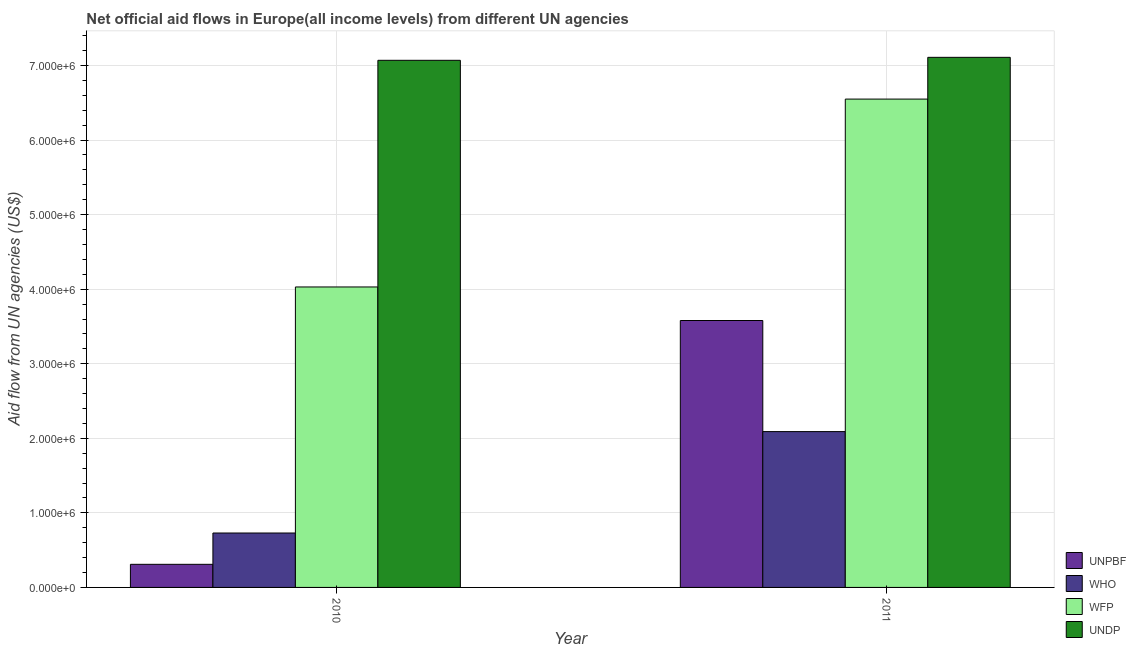How many different coloured bars are there?
Keep it short and to the point. 4. How many groups of bars are there?
Provide a short and direct response. 2. Are the number of bars on each tick of the X-axis equal?
Offer a very short reply. Yes. How many bars are there on the 2nd tick from the left?
Ensure brevity in your answer.  4. How many bars are there on the 1st tick from the right?
Make the answer very short. 4. What is the label of the 2nd group of bars from the left?
Your response must be concise. 2011. What is the amount of aid given by undp in 2010?
Your answer should be very brief. 7.07e+06. Across all years, what is the maximum amount of aid given by wfp?
Your answer should be compact. 6.55e+06. Across all years, what is the minimum amount of aid given by wfp?
Keep it short and to the point. 4.03e+06. In which year was the amount of aid given by unpbf maximum?
Keep it short and to the point. 2011. What is the total amount of aid given by unpbf in the graph?
Keep it short and to the point. 3.89e+06. What is the difference between the amount of aid given by undp in 2010 and that in 2011?
Provide a succinct answer. -4.00e+04. What is the difference between the amount of aid given by unpbf in 2010 and the amount of aid given by undp in 2011?
Provide a succinct answer. -3.27e+06. What is the average amount of aid given by who per year?
Offer a terse response. 1.41e+06. What is the ratio of the amount of aid given by undp in 2010 to that in 2011?
Offer a terse response. 0.99. Is the amount of aid given by who in 2010 less than that in 2011?
Offer a terse response. Yes. In how many years, is the amount of aid given by wfp greater than the average amount of aid given by wfp taken over all years?
Your response must be concise. 1. What does the 2nd bar from the left in 2011 represents?
Provide a short and direct response. WHO. What does the 1st bar from the right in 2010 represents?
Offer a very short reply. UNDP. Is it the case that in every year, the sum of the amount of aid given by unpbf and amount of aid given by who is greater than the amount of aid given by wfp?
Provide a short and direct response. No. Are all the bars in the graph horizontal?
Provide a short and direct response. No. How many years are there in the graph?
Provide a succinct answer. 2. What is the title of the graph?
Make the answer very short. Net official aid flows in Europe(all income levels) from different UN agencies. What is the label or title of the Y-axis?
Your answer should be very brief. Aid flow from UN agencies (US$). What is the Aid flow from UN agencies (US$) in WHO in 2010?
Provide a succinct answer. 7.30e+05. What is the Aid flow from UN agencies (US$) of WFP in 2010?
Your response must be concise. 4.03e+06. What is the Aid flow from UN agencies (US$) in UNDP in 2010?
Give a very brief answer. 7.07e+06. What is the Aid flow from UN agencies (US$) of UNPBF in 2011?
Keep it short and to the point. 3.58e+06. What is the Aid flow from UN agencies (US$) of WHO in 2011?
Your answer should be very brief. 2.09e+06. What is the Aid flow from UN agencies (US$) of WFP in 2011?
Make the answer very short. 6.55e+06. What is the Aid flow from UN agencies (US$) in UNDP in 2011?
Your answer should be compact. 7.11e+06. Across all years, what is the maximum Aid flow from UN agencies (US$) in UNPBF?
Offer a terse response. 3.58e+06. Across all years, what is the maximum Aid flow from UN agencies (US$) in WHO?
Your response must be concise. 2.09e+06. Across all years, what is the maximum Aid flow from UN agencies (US$) in WFP?
Make the answer very short. 6.55e+06. Across all years, what is the maximum Aid flow from UN agencies (US$) of UNDP?
Make the answer very short. 7.11e+06. Across all years, what is the minimum Aid flow from UN agencies (US$) in UNPBF?
Keep it short and to the point. 3.10e+05. Across all years, what is the minimum Aid flow from UN agencies (US$) of WHO?
Your answer should be very brief. 7.30e+05. Across all years, what is the minimum Aid flow from UN agencies (US$) of WFP?
Give a very brief answer. 4.03e+06. Across all years, what is the minimum Aid flow from UN agencies (US$) of UNDP?
Your response must be concise. 7.07e+06. What is the total Aid flow from UN agencies (US$) of UNPBF in the graph?
Provide a short and direct response. 3.89e+06. What is the total Aid flow from UN agencies (US$) of WHO in the graph?
Give a very brief answer. 2.82e+06. What is the total Aid flow from UN agencies (US$) in WFP in the graph?
Give a very brief answer. 1.06e+07. What is the total Aid flow from UN agencies (US$) of UNDP in the graph?
Your response must be concise. 1.42e+07. What is the difference between the Aid flow from UN agencies (US$) in UNPBF in 2010 and that in 2011?
Your answer should be compact. -3.27e+06. What is the difference between the Aid flow from UN agencies (US$) in WHO in 2010 and that in 2011?
Offer a very short reply. -1.36e+06. What is the difference between the Aid flow from UN agencies (US$) of WFP in 2010 and that in 2011?
Give a very brief answer. -2.52e+06. What is the difference between the Aid flow from UN agencies (US$) of UNPBF in 2010 and the Aid flow from UN agencies (US$) of WHO in 2011?
Your response must be concise. -1.78e+06. What is the difference between the Aid flow from UN agencies (US$) of UNPBF in 2010 and the Aid flow from UN agencies (US$) of WFP in 2011?
Ensure brevity in your answer.  -6.24e+06. What is the difference between the Aid flow from UN agencies (US$) in UNPBF in 2010 and the Aid flow from UN agencies (US$) in UNDP in 2011?
Offer a terse response. -6.80e+06. What is the difference between the Aid flow from UN agencies (US$) of WHO in 2010 and the Aid flow from UN agencies (US$) of WFP in 2011?
Offer a terse response. -5.82e+06. What is the difference between the Aid flow from UN agencies (US$) of WHO in 2010 and the Aid flow from UN agencies (US$) of UNDP in 2011?
Your answer should be very brief. -6.38e+06. What is the difference between the Aid flow from UN agencies (US$) of WFP in 2010 and the Aid flow from UN agencies (US$) of UNDP in 2011?
Make the answer very short. -3.08e+06. What is the average Aid flow from UN agencies (US$) in UNPBF per year?
Keep it short and to the point. 1.94e+06. What is the average Aid flow from UN agencies (US$) in WHO per year?
Your response must be concise. 1.41e+06. What is the average Aid flow from UN agencies (US$) in WFP per year?
Provide a succinct answer. 5.29e+06. What is the average Aid flow from UN agencies (US$) in UNDP per year?
Your answer should be very brief. 7.09e+06. In the year 2010, what is the difference between the Aid flow from UN agencies (US$) of UNPBF and Aid flow from UN agencies (US$) of WHO?
Your response must be concise. -4.20e+05. In the year 2010, what is the difference between the Aid flow from UN agencies (US$) of UNPBF and Aid flow from UN agencies (US$) of WFP?
Your answer should be very brief. -3.72e+06. In the year 2010, what is the difference between the Aid flow from UN agencies (US$) in UNPBF and Aid flow from UN agencies (US$) in UNDP?
Your answer should be very brief. -6.76e+06. In the year 2010, what is the difference between the Aid flow from UN agencies (US$) of WHO and Aid flow from UN agencies (US$) of WFP?
Make the answer very short. -3.30e+06. In the year 2010, what is the difference between the Aid flow from UN agencies (US$) of WHO and Aid flow from UN agencies (US$) of UNDP?
Your answer should be compact. -6.34e+06. In the year 2010, what is the difference between the Aid flow from UN agencies (US$) in WFP and Aid flow from UN agencies (US$) in UNDP?
Ensure brevity in your answer.  -3.04e+06. In the year 2011, what is the difference between the Aid flow from UN agencies (US$) in UNPBF and Aid flow from UN agencies (US$) in WHO?
Your response must be concise. 1.49e+06. In the year 2011, what is the difference between the Aid flow from UN agencies (US$) in UNPBF and Aid flow from UN agencies (US$) in WFP?
Keep it short and to the point. -2.97e+06. In the year 2011, what is the difference between the Aid flow from UN agencies (US$) of UNPBF and Aid flow from UN agencies (US$) of UNDP?
Offer a terse response. -3.53e+06. In the year 2011, what is the difference between the Aid flow from UN agencies (US$) in WHO and Aid flow from UN agencies (US$) in WFP?
Offer a very short reply. -4.46e+06. In the year 2011, what is the difference between the Aid flow from UN agencies (US$) in WHO and Aid flow from UN agencies (US$) in UNDP?
Give a very brief answer. -5.02e+06. In the year 2011, what is the difference between the Aid flow from UN agencies (US$) in WFP and Aid flow from UN agencies (US$) in UNDP?
Offer a terse response. -5.60e+05. What is the ratio of the Aid flow from UN agencies (US$) of UNPBF in 2010 to that in 2011?
Give a very brief answer. 0.09. What is the ratio of the Aid flow from UN agencies (US$) of WHO in 2010 to that in 2011?
Provide a succinct answer. 0.35. What is the ratio of the Aid flow from UN agencies (US$) of WFP in 2010 to that in 2011?
Offer a terse response. 0.62. What is the ratio of the Aid flow from UN agencies (US$) of UNDP in 2010 to that in 2011?
Give a very brief answer. 0.99. What is the difference between the highest and the second highest Aid flow from UN agencies (US$) in UNPBF?
Provide a succinct answer. 3.27e+06. What is the difference between the highest and the second highest Aid flow from UN agencies (US$) in WHO?
Keep it short and to the point. 1.36e+06. What is the difference between the highest and the second highest Aid flow from UN agencies (US$) in WFP?
Provide a succinct answer. 2.52e+06. What is the difference between the highest and the second highest Aid flow from UN agencies (US$) of UNDP?
Offer a terse response. 4.00e+04. What is the difference between the highest and the lowest Aid flow from UN agencies (US$) of UNPBF?
Keep it short and to the point. 3.27e+06. What is the difference between the highest and the lowest Aid flow from UN agencies (US$) in WHO?
Your answer should be very brief. 1.36e+06. What is the difference between the highest and the lowest Aid flow from UN agencies (US$) of WFP?
Keep it short and to the point. 2.52e+06. What is the difference between the highest and the lowest Aid flow from UN agencies (US$) in UNDP?
Give a very brief answer. 4.00e+04. 